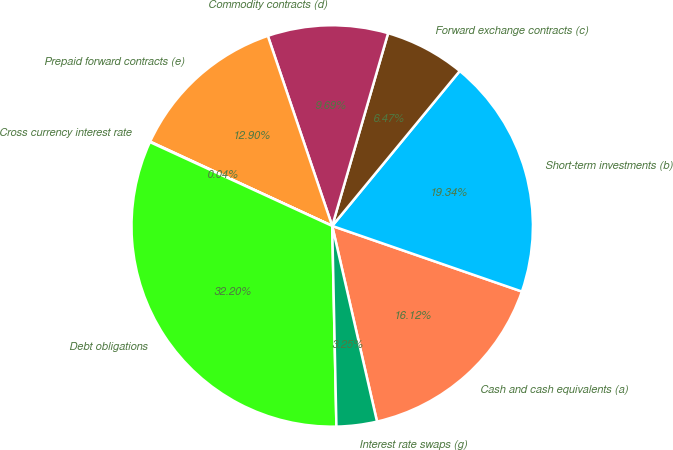Convert chart. <chart><loc_0><loc_0><loc_500><loc_500><pie_chart><fcel>Cash and cash equivalents (a)<fcel>Short-term investments (b)<fcel>Forward exchange contracts (c)<fcel>Commodity contracts (d)<fcel>Prepaid forward contracts (e)<fcel>Cross currency interest rate<fcel>Debt obligations<fcel>Interest rate swaps (g)<nl><fcel>16.12%<fcel>19.34%<fcel>6.47%<fcel>9.69%<fcel>12.9%<fcel>0.04%<fcel>32.2%<fcel>3.25%<nl></chart> 